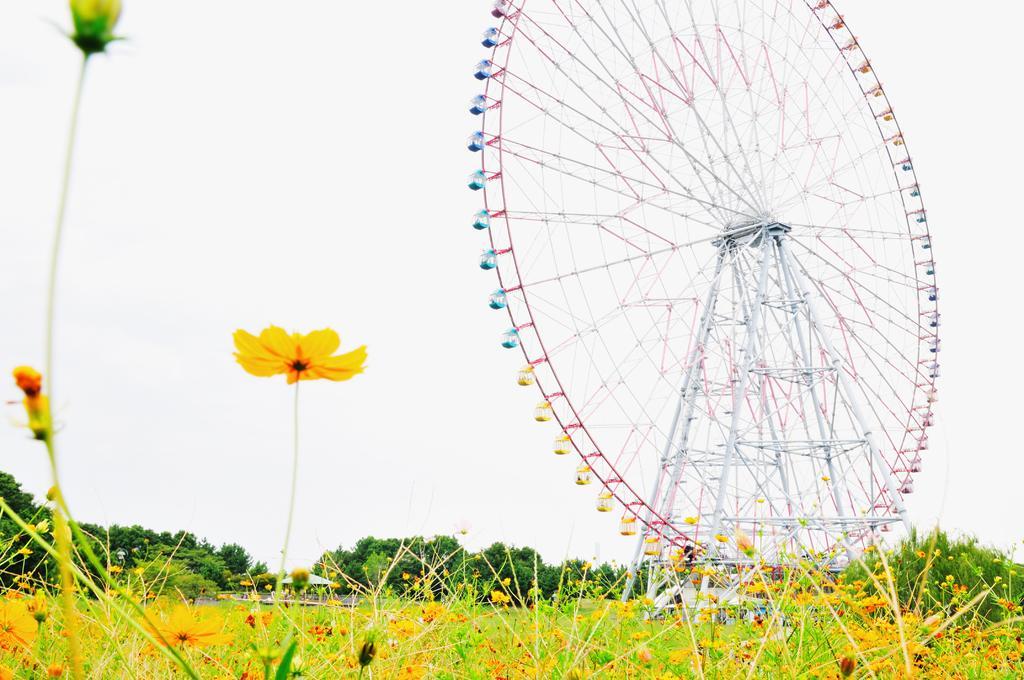Please provide a concise description of this image. In the image we can see there are flowers on the plants and the ground is covered with plants. Behind there are trees and there is a huge giant wheel kept on the ground. There is clear sky on the top. 